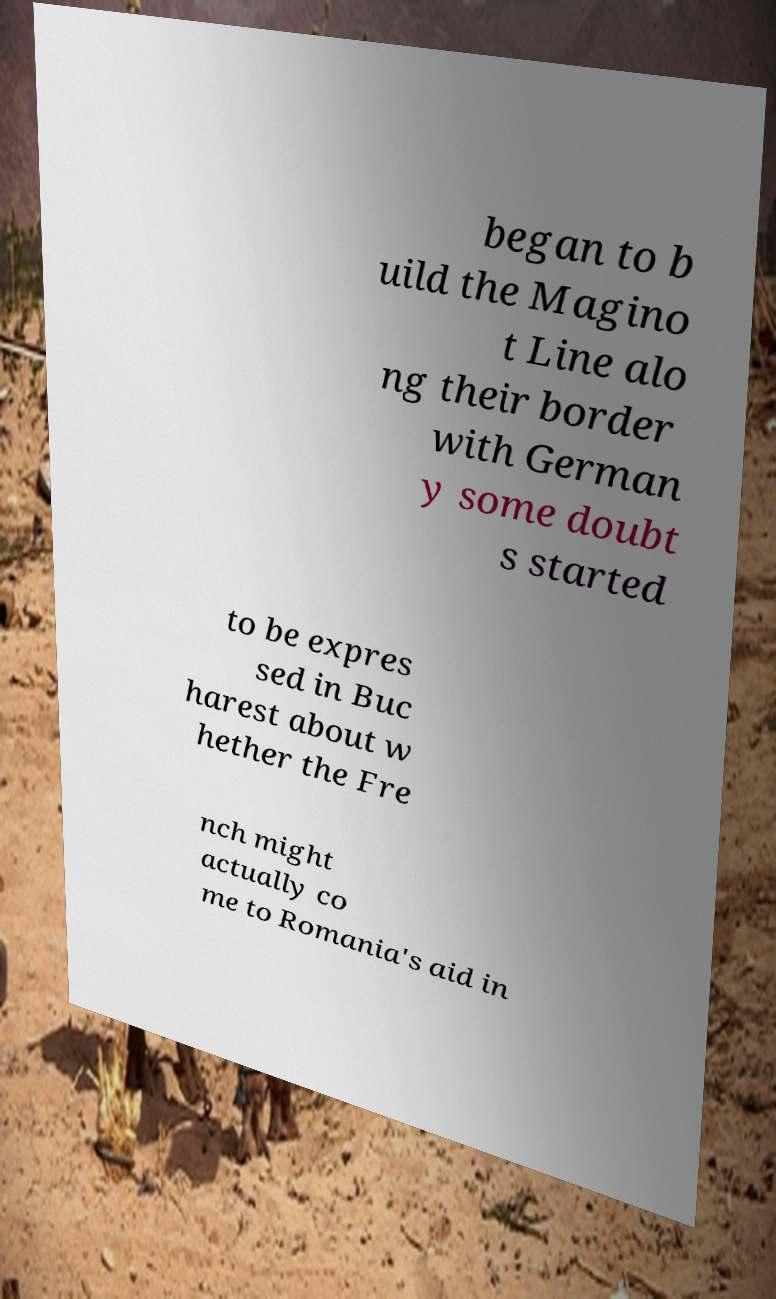Can you accurately transcribe the text from the provided image for me? began to b uild the Magino t Line alo ng their border with German y some doubt s started to be expres sed in Buc harest about w hether the Fre nch might actually co me to Romania's aid in 